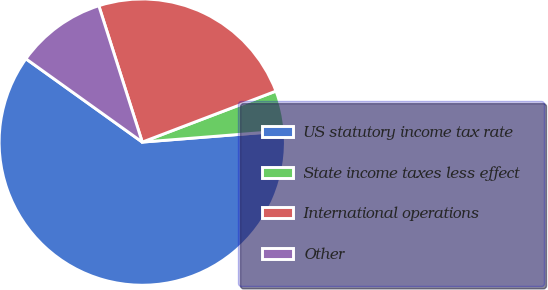<chart> <loc_0><loc_0><loc_500><loc_500><pie_chart><fcel>US statutory income tax rate<fcel>State income taxes less effect<fcel>International operations<fcel>Other<nl><fcel>61.15%<fcel>4.54%<fcel>24.11%<fcel>10.2%<nl></chart> 